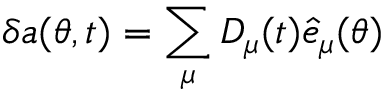<formula> <loc_0><loc_0><loc_500><loc_500>\delta a ( \theta , t ) = \sum _ { \mu } D _ { \mu } ( t ) { \hat { e } _ { \mu } ( \theta ) }</formula> 